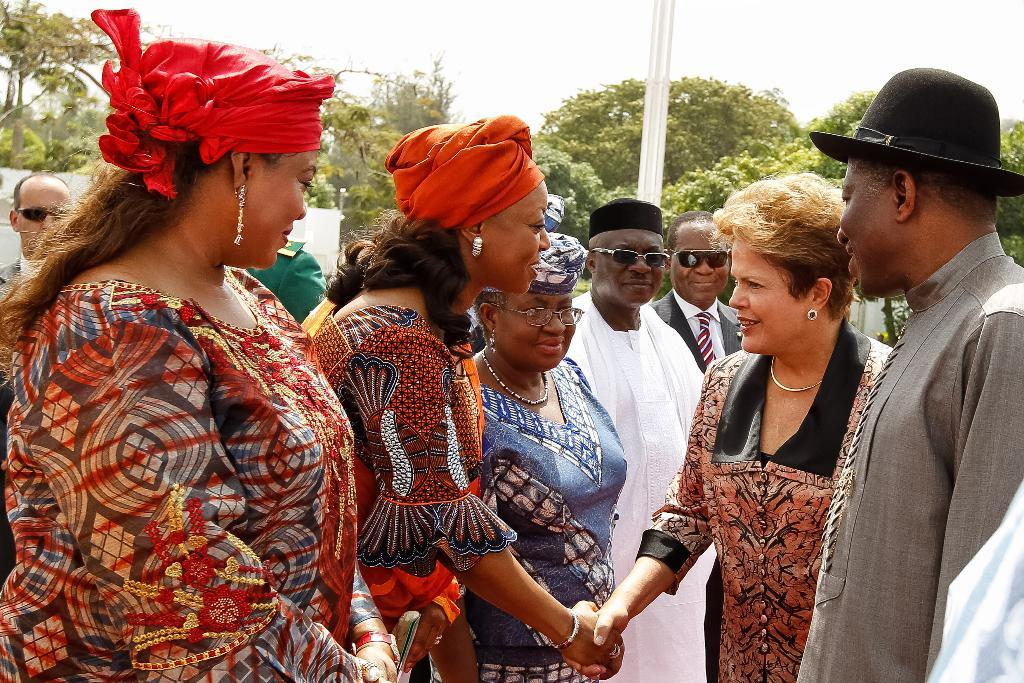What are the people in the image doing? The persons standing on the ground in the image are likely standing or perhaps waiting. What can be seen in the background of the image? There are trees and a pole in the background of the image. What is visible in the sky in the image? The sky is visible in the background of the image. What type of money is being exchanged between the persons in the image? There is no indication of any money exchange in the image; the persons are simply standing on the ground. What kind of beast can be seen hiding behind the pole in the image? There is no beast present in the image; only trees, a pole, and the sky are visible in the background. 